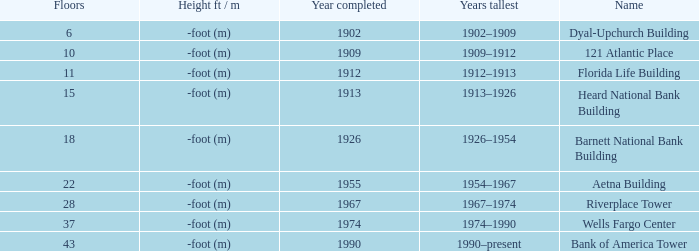What was the name of the building with 10 floors? 121 Atlantic Place. 